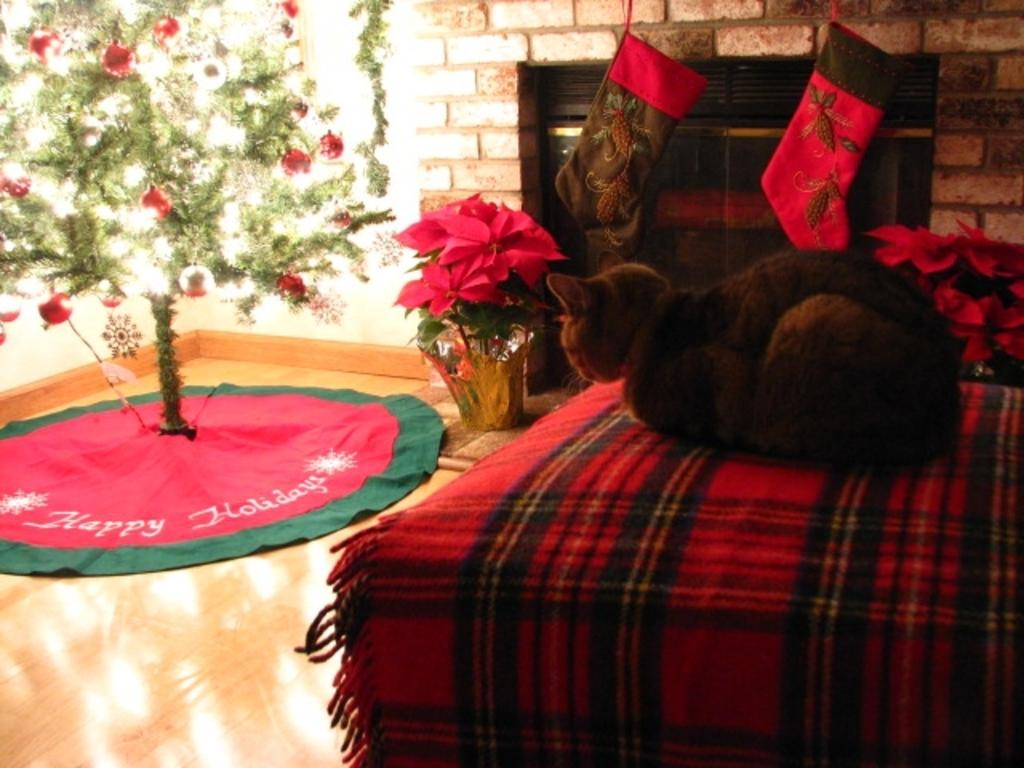What animal can be seen on the bed in the foreground? There is a cat on the bed in the foreground. What is located on the left side of the image? There is a Xmas tree on the left side of the image. What is the Xmas tree placed on? The Xmas tree is on a surface. What items can be seen in the background of the image? There are socks and a flower pot in the background. What is visible in the background of the image? There is a wall visible in the background. Can you tell me how many tomatoes are on the cat's paws in the image? There are no tomatoes present in the image, and the cat's paws are not visible. Is there an insect crawling on the Xmas tree in the image? There is no insect visible on the Xmas tree in the image. 